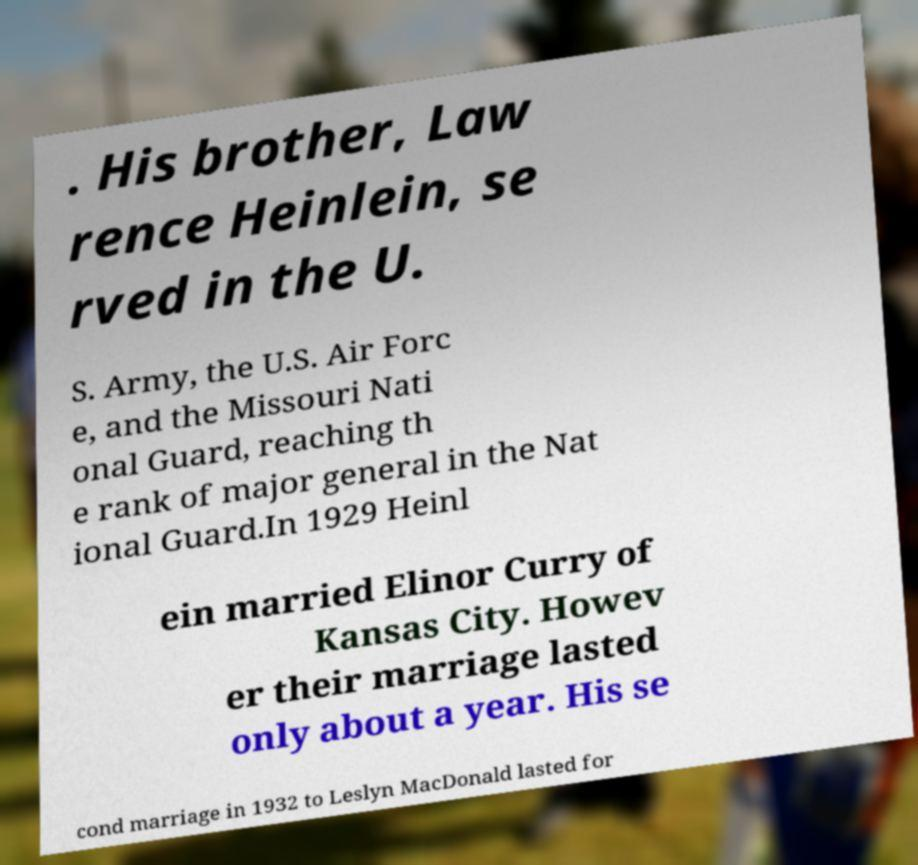I need the written content from this picture converted into text. Can you do that? . His brother, Law rence Heinlein, se rved in the U. S. Army, the U.S. Air Forc e, and the Missouri Nati onal Guard, reaching th e rank of major general in the Nat ional Guard.In 1929 Heinl ein married Elinor Curry of Kansas City. Howev er their marriage lasted only about a year. His se cond marriage in 1932 to Leslyn MacDonald lasted for 